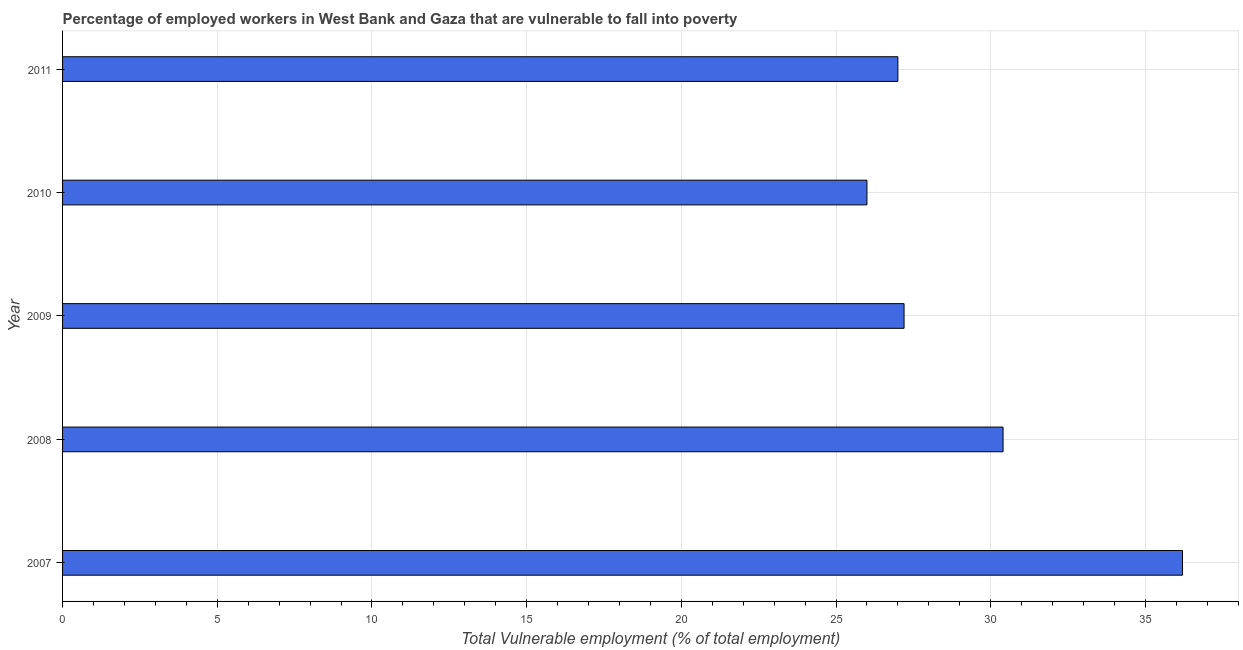Does the graph contain any zero values?
Your answer should be very brief. No. Does the graph contain grids?
Provide a short and direct response. Yes. What is the title of the graph?
Give a very brief answer. Percentage of employed workers in West Bank and Gaza that are vulnerable to fall into poverty. What is the label or title of the X-axis?
Your response must be concise. Total Vulnerable employment (% of total employment). What is the label or title of the Y-axis?
Your answer should be very brief. Year. What is the total vulnerable employment in 2008?
Provide a short and direct response. 30.4. Across all years, what is the maximum total vulnerable employment?
Your answer should be compact. 36.2. In which year was the total vulnerable employment maximum?
Provide a short and direct response. 2007. In which year was the total vulnerable employment minimum?
Provide a short and direct response. 2010. What is the sum of the total vulnerable employment?
Your answer should be compact. 146.8. What is the difference between the total vulnerable employment in 2008 and 2011?
Offer a very short reply. 3.4. What is the average total vulnerable employment per year?
Make the answer very short. 29.36. What is the median total vulnerable employment?
Your answer should be compact. 27.2. In how many years, is the total vulnerable employment greater than 17 %?
Offer a terse response. 5. What is the difference between the highest and the second highest total vulnerable employment?
Keep it short and to the point. 5.8. What is the difference between the highest and the lowest total vulnerable employment?
Provide a succinct answer. 10.2. How many bars are there?
Keep it short and to the point. 5. What is the Total Vulnerable employment (% of total employment) in 2007?
Provide a succinct answer. 36.2. What is the Total Vulnerable employment (% of total employment) in 2008?
Ensure brevity in your answer.  30.4. What is the Total Vulnerable employment (% of total employment) in 2009?
Provide a succinct answer. 27.2. What is the Total Vulnerable employment (% of total employment) of 2010?
Give a very brief answer. 26. What is the difference between the Total Vulnerable employment (% of total employment) in 2007 and 2009?
Make the answer very short. 9. What is the difference between the Total Vulnerable employment (% of total employment) in 2007 and 2010?
Provide a succinct answer. 10.2. What is the difference between the Total Vulnerable employment (% of total employment) in 2007 and 2011?
Your answer should be very brief. 9.2. What is the difference between the Total Vulnerable employment (% of total employment) in 2008 and 2010?
Your answer should be compact. 4.4. What is the difference between the Total Vulnerable employment (% of total employment) in 2008 and 2011?
Your response must be concise. 3.4. What is the difference between the Total Vulnerable employment (% of total employment) in 2009 and 2010?
Provide a succinct answer. 1.2. What is the ratio of the Total Vulnerable employment (% of total employment) in 2007 to that in 2008?
Provide a short and direct response. 1.19. What is the ratio of the Total Vulnerable employment (% of total employment) in 2007 to that in 2009?
Your answer should be compact. 1.33. What is the ratio of the Total Vulnerable employment (% of total employment) in 2007 to that in 2010?
Provide a short and direct response. 1.39. What is the ratio of the Total Vulnerable employment (% of total employment) in 2007 to that in 2011?
Offer a terse response. 1.34. What is the ratio of the Total Vulnerable employment (% of total employment) in 2008 to that in 2009?
Give a very brief answer. 1.12. What is the ratio of the Total Vulnerable employment (% of total employment) in 2008 to that in 2010?
Your answer should be very brief. 1.17. What is the ratio of the Total Vulnerable employment (% of total employment) in 2008 to that in 2011?
Your response must be concise. 1.13. What is the ratio of the Total Vulnerable employment (% of total employment) in 2009 to that in 2010?
Give a very brief answer. 1.05. What is the ratio of the Total Vulnerable employment (% of total employment) in 2009 to that in 2011?
Offer a very short reply. 1.01. What is the ratio of the Total Vulnerable employment (% of total employment) in 2010 to that in 2011?
Ensure brevity in your answer.  0.96. 